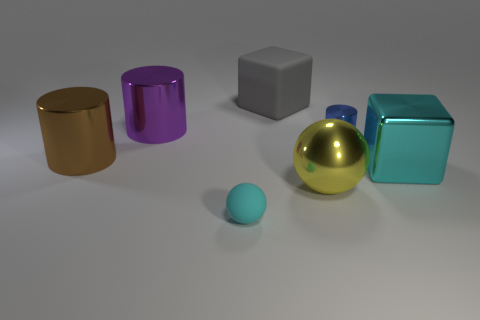There is a brown cylinder that is the same size as the cyan block; what material is it?
Offer a terse response. Metal. There is a purple shiny thing; is it the same size as the shiny cylinder to the right of the metal sphere?
Your answer should be compact. No. Do the blue metallic cylinder and the brown metal cylinder have the same size?
Your response must be concise. No. There is a cyan thing that is the same shape as the big yellow metallic object; what material is it?
Provide a short and direct response. Rubber. What size is the cyan thing that is in front of the object that is to the right of the tiny thing on the right side of the gray matte cube?
Your answer should be very brief. Small. What number of other objects are there of the same color as the big shiny cube?
Provide a short and direct response. 1. The big thing that is in front of the cube that is in front of the big brown metallic object is made of what material?
Your answer should be compact. Metal. What is the size of the cylinder that is to the right of the large block on the left side of the big cyan block?
Offer a very short reply. Small. The large shiny ball has what color?
Offer a terse response. Yellow. What color is the other big thing that is the same shape as the large gray thing?
Give a very brief answer. Cyan. 